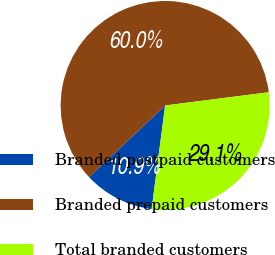<chart> <loc_0><loc_0><loc_500><loc_500><pie_chart><fcel>Branded postpaid customers<fcel>Branded prepaid customers<fcel>Total branded customers<nl><fcel>10.91%<fcel>60.0%<fcel>29.09%<nl></chart> 